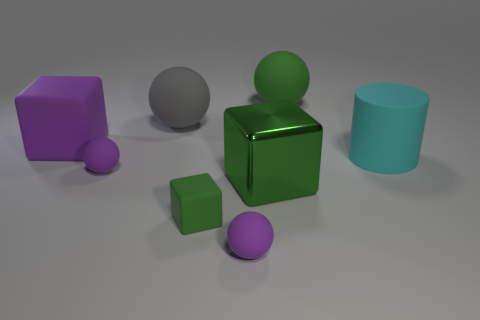Subtract all green cubes. How many cubes are left? 1 Add 1 tiny spheres. How many objects exist? 9 Subtract all red cubes. How many purple spheres are left? 2 Subtract all green balls. How many balls are left? 3 Subtract all cylinders. Subtract all big cyan cylinders. How many objects are left? 6 Add 5 large gray balls. How many large gray balls are left? 6 Add 4 large matte spheres. How many large matte spheres exist? 6 Subtract 1 green cubes. How many objects are left? 7 Subtract all cylinders. How many objects are left? 7 Subtract all cyan cubes. Subtract all green cylinders. How many cubes are left? 3 